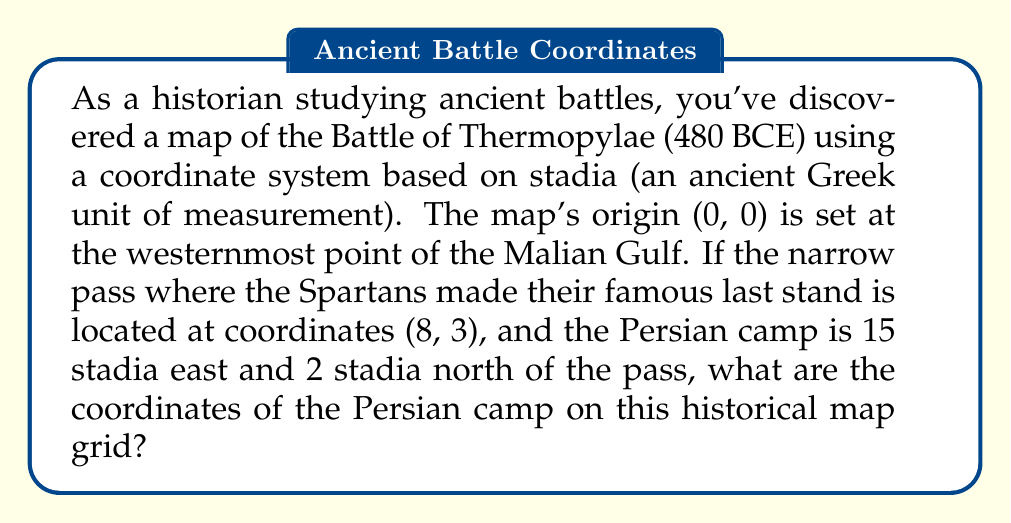What is the answer to this math problem? To solve this problem, we need to use vector addition in a two-dimensional coordinate system. Let's break it down step-by-step:

1. We're given the coordinates of the narrow pass: (8, 3)

2. The Persian camp's position is described relative to the pass:
   - 15 stadia east (positive x-direction)
   - 2 stadia north (positive y-direction)

3. We can represent this as a vector: $\vec{v} = (15, 2)$

4. To find the Persian camp's coordinates, we add this vector to the coordinates of the pass:

   $$(x_{camp}, y_{camp}) = (x_{pass}, y_{pass}) + (x_{vector}, y_{vector})$$

   $$(x_{camp}, y_{camp}) = (8, 3) + (15, 2)$$

5. Performing the vector addition:

   $$x_{camp} = 8 + 15 = 23$$
   $$y_{camp} = 3 + 2 = 5$$

Therefore, the coordinates of the Persian camp are (23, 5) on the historical map grid.

This method of using coordinate systems to analyze historical battle sites can provide valuable insights into military strategies and the geographical context of ancient conflicts.
Answer: (23, 5) 